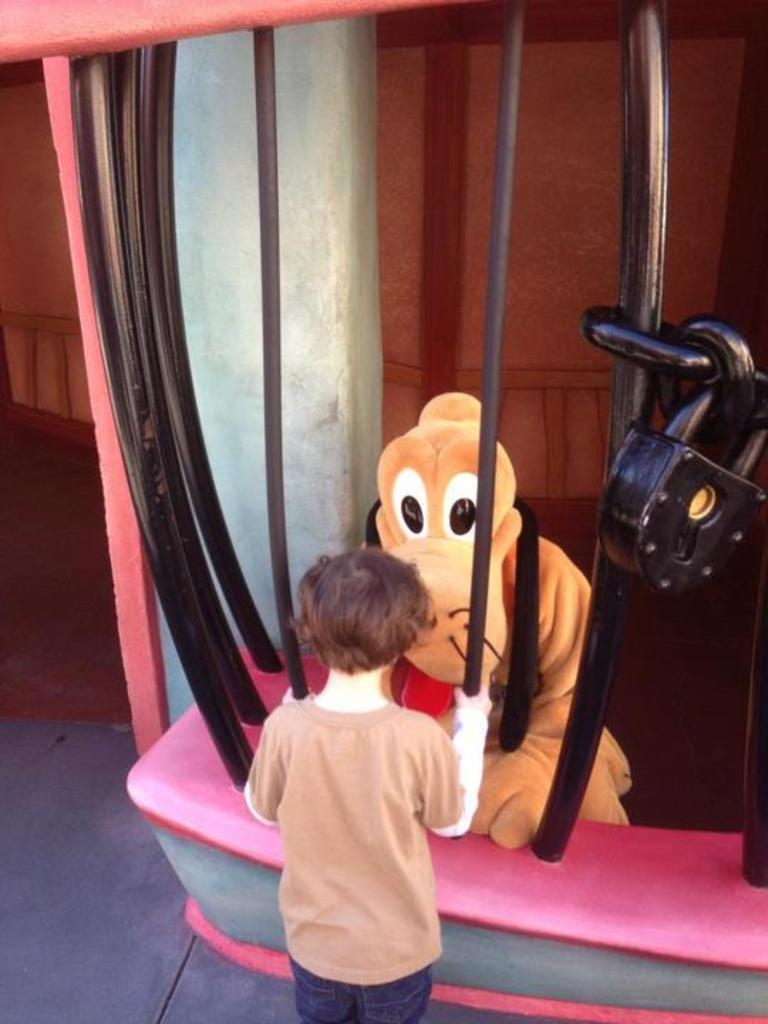What is the main subject of the image? The main subject of the image is a kid. What object can be seen with the kid in the image? There is a toy in the image. What can be seen in the background of the image? There is a wall in the background of the image. What type of ornament is hanging from the ceiling in the image? There is no ornament hanging from the ceiling in the image. What statement is the kid making in the image? The image does not show the kid making any statement. 